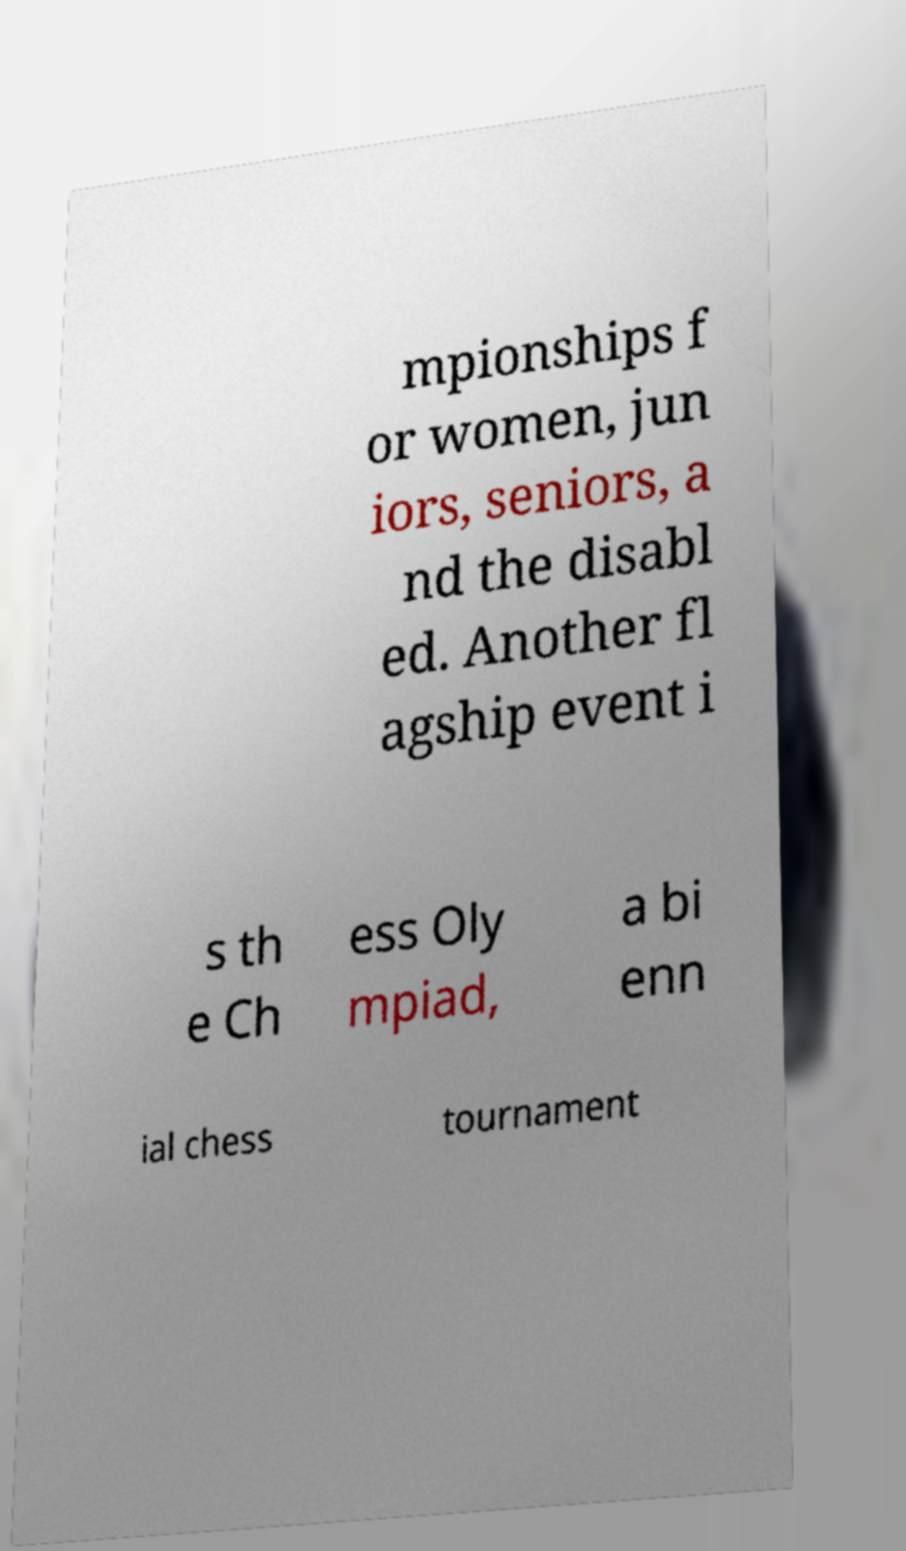Please read and relay the text visible in this image. What does it say? mpionships f or women, jun iors, seniors, a nd the disabl ed. Another fl agship event i s th e Ch ess Oly mpiad, a bi enn ial chess tournament 